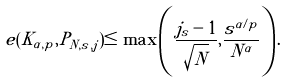Convert formula to latex. <formula><loc_0><loc_0><loc_500><loc_500>e ( K _ { \alpha , p } , P _ { N , s , j } ) \leq \max \left ( \frac { j _ { s } - 1 } { \sqrt { N } } , \frac { s ^ { \alpha / p } } { N ^ { \alpha } } \right ) .</formula> 